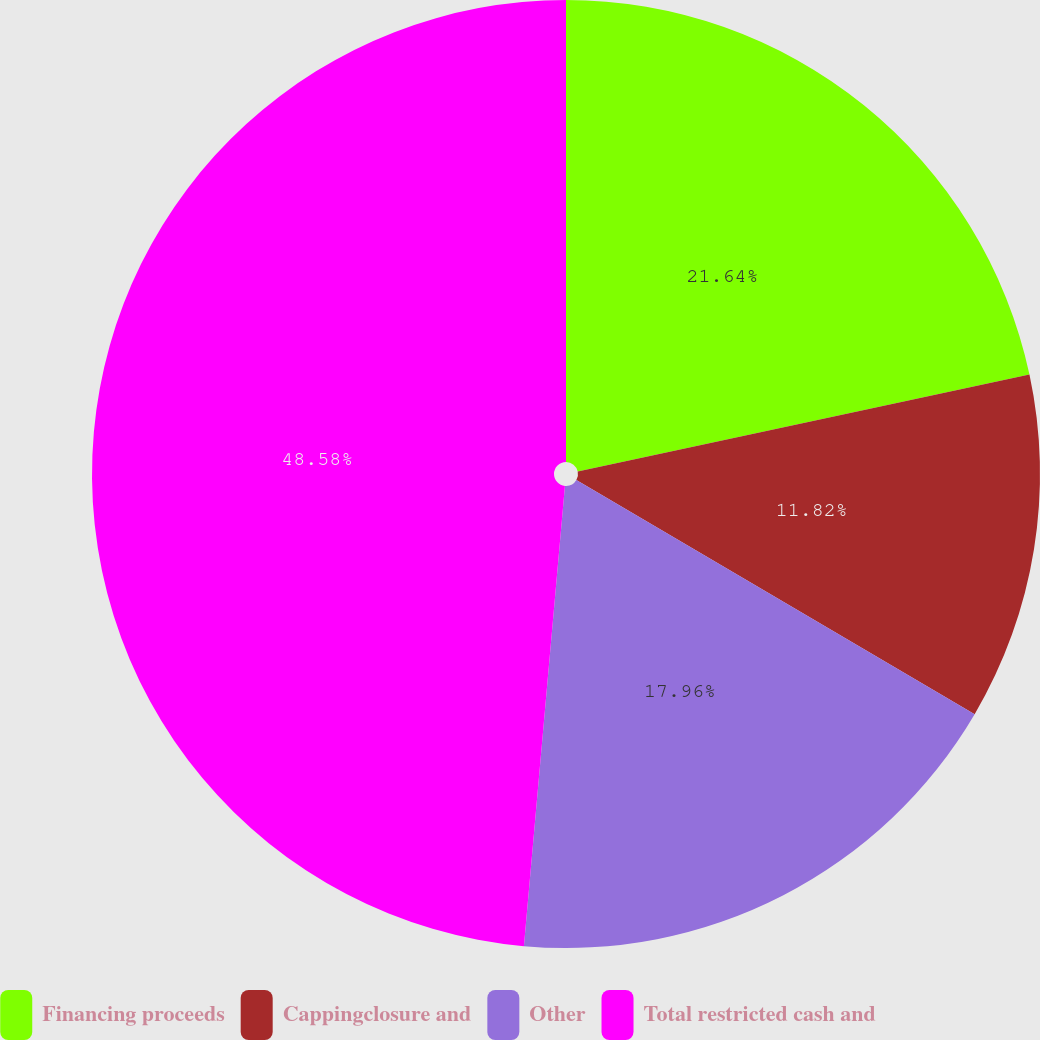Convert chart to OTSL. <chart><loc_0><loc_0><loc_500><loc_500><pie_chart><fcel>Financing proceeds<fcel>Cappingclosure and<fcel>Other<fcel>Total restricted cash and<nl><fcel>21.64%<fcel>11.82%<fcel>17.96%<fcel>48.59%<nl></chart> 